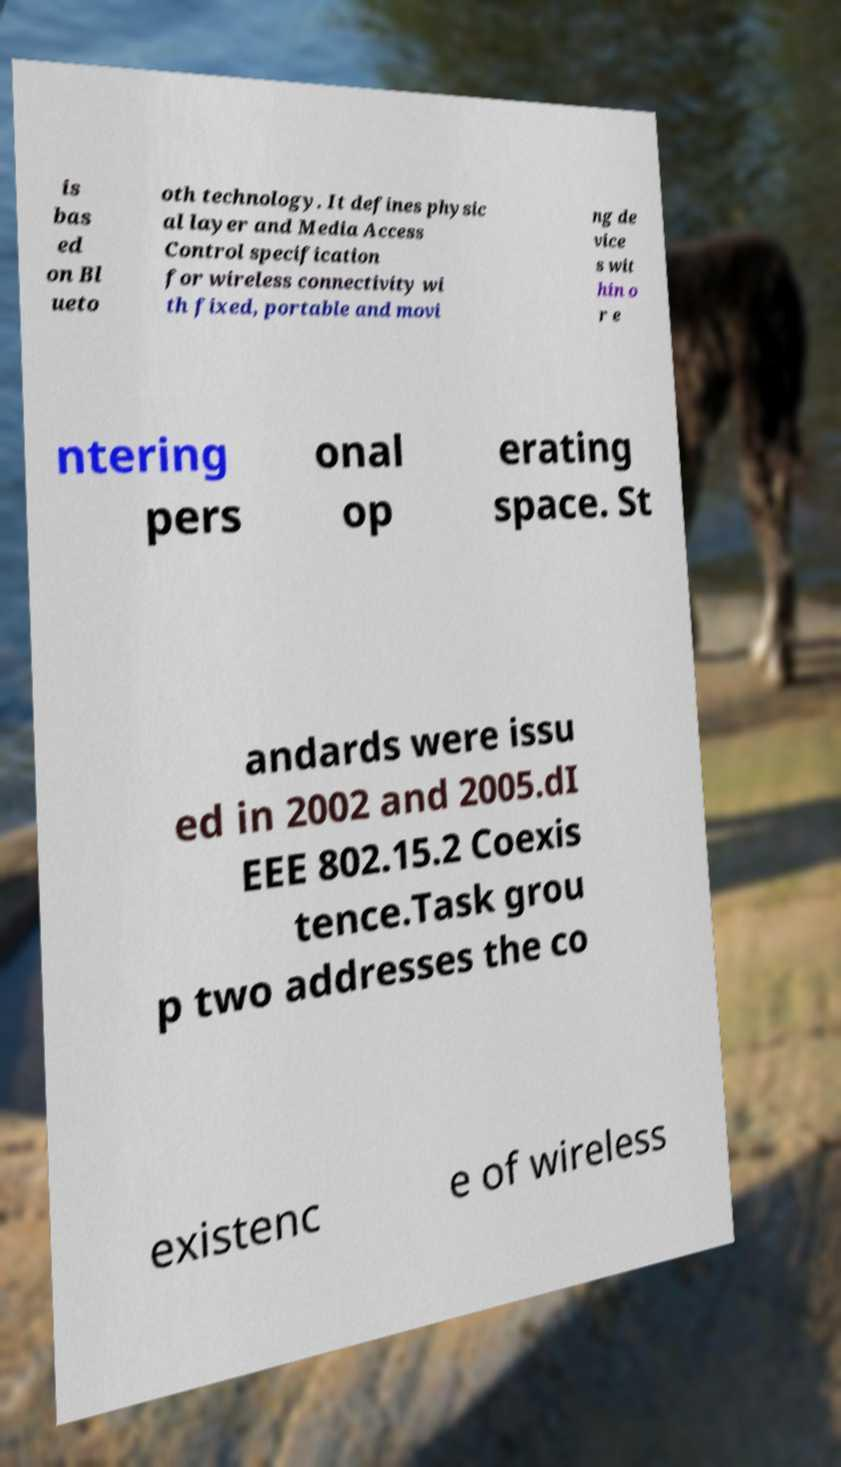I need the written content from this picture converted into text. Can you do that? is bas ed on Bl ueto oth technology. It defines physic al layer and Media Access Control specification for wireless connectivity wi th fixed, portable and movi ng de vice s wit hin o r e ntering pers onal op erating space. St andards were issu ed in 2002 and 2005.dI EEE 802.15.2 Coexis tence.Task grou p two addresses the co existenc e of wireless 